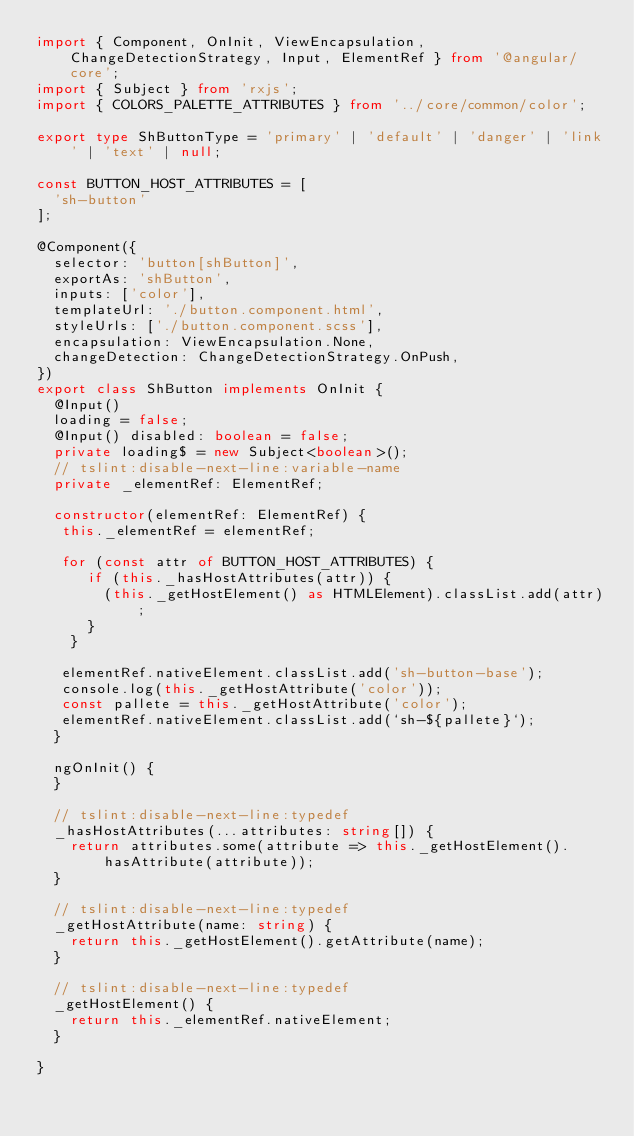<code> <loc_0><loc_0><loc_500><loc_500><_TypeScript_>import { Component, OnInit, ViewEncapsulation, ChangeDetectionStrategy, Input, ElementRef } from '@angular/core';
import { Subject } from 'rxjs';
import { COLORS_PALETTE_ATTRIBUTES } from '../core/common/color';

export type ShButtonType = 'primary' | 'default' | 'danger' | 'link' | 'text' | null;

const BUTTON_HOST_ATTRIBUTES = [
  'sh-button'
];

@Component({
  selector: 'button[shButton]',
  exportAs: 'shButton',
  inputs: ['color'],
  templateUrl: './button.component.html',
  styleUrls: ['./button.component.scss'],
  encapsulation: ViewEncapsulation.None,
  changeDetection: ChangeDetectionStrategy.OnPush,
})
export class ShButton implements OnInit {
  @Input()
  loading = false;
  @Input() disabled: boolean = false;
  private loading$ = new Subject<boolean>();
  // tslint:disable-next-line:variable-name
  private _elementRef: ElementRef;

  constructor(elementRef: ElementRef) {
   this._elementRef = elementRef;

   for (const attr of BUTTON_HOST_ATTRIBUTES) {
      if (this._hasHostAttributes(attr)) {
        (this._getHostElement() as HTMLElement).classList.add(attr);
      }
    }

   elementRef.nativeElement.classList.add('sh-button-base');
   console.log(this._getHostAttribute('color'));
   const pallete = this._getHostAttribute('color');
   elementRef.nativeElement.classList.add(`sh-${pallete}`);
  }

  ngOnInit() {
  }

  // tslint:disable-next-line:typedef
  _hasHostAttributes(...attributes: string[]) {
    return attributes.some(attribute => this._getHostElement().hasAttribute(attribute));
  }

  // tslint:disable-next-line:typedef
  _getHostAttribute(name: string) {
    return this._getHostElement().getAttribute(name);
  }

  // tslint:disable-next-line:typedef
  _getHostElement() {
    return this._elementRef.nativeElement;
  }

}
</code> 